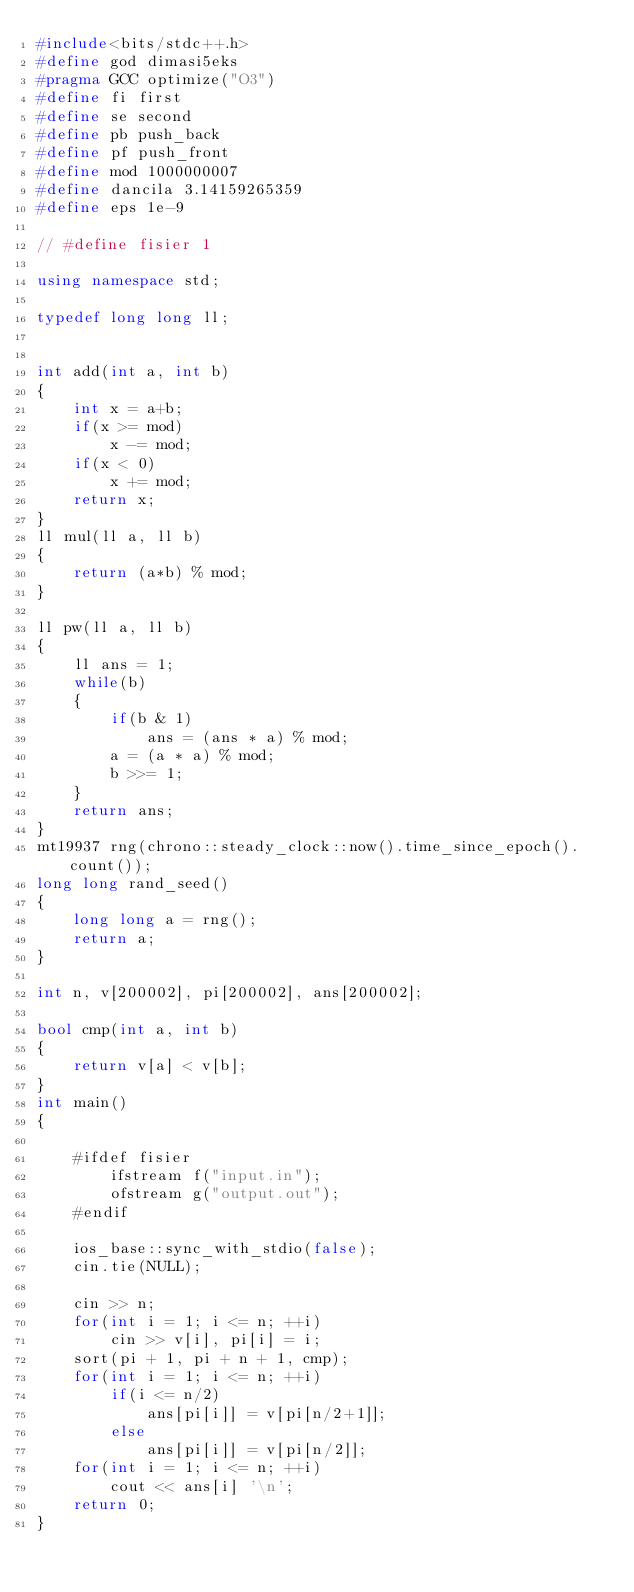Convert code to text. <code><loc_0><loc_0><loc_500><loc_500><_C++_>#include<bits/stdc++.h>
#define god dimasi5eks
#pragma GCC optimize("O3")
#define fi first
#define se second
#define pb push_back
#define pf push_front
#define mod 1000000007
#define dancila 3.14159265359
#define eps 1e-9

// #define fisier 1

using namespace std;

typedef long long ll;


int add(int a, int b)
{
    int x = a+b;
    if(x >= mod)
        x -= mod;
    if(x < 0)
        x += mod;
    return x;
}
ll mul(ll a, ll b)
{
    return (a*b) % mod;
}

ll pw(ll a, ll b)
{
    ll ans = 1;
    while(b)
    {
        if(b & 1)
            ans = (ans * a) % mod;
        a = (a * a) % mod;
        b >>= 1;
    }
    return ans;
}
mt19937 rng(chrono::steady_clock::now().time_since_epoch().count());
long long rand_seed()
{
    long long a = rng();
    return a;
}

int n, v[200002], pi[200002], ans[200002];

bool cmp(int a, int b)
{
    return v[a] < v[b];
}
int main()
{

    #ifdef fisier
        ifstream f("input.in");
        ofstream g("output.out");
    #endif

    ios_base::sync_with_stdio(false);
    cin.tie(NULL);

    cin >> n;
    for(int i = 1; i <= n; ++i)
        cin >> v[i], pi[i] = i;
    sort(pi + 1, pi + n + 1, cmp);
    for(int i = 1; i <= n; ++i)
        if(i <= n/2)
            ans[pi[i]] = v[pi[n/2+1]];
        else
            ans[pi[i]] = v[pi[n/2]];
    for(int i = 1; i <= n; ++i)
        cout << ans[i] '\n';
    return 0;
}
</code> 